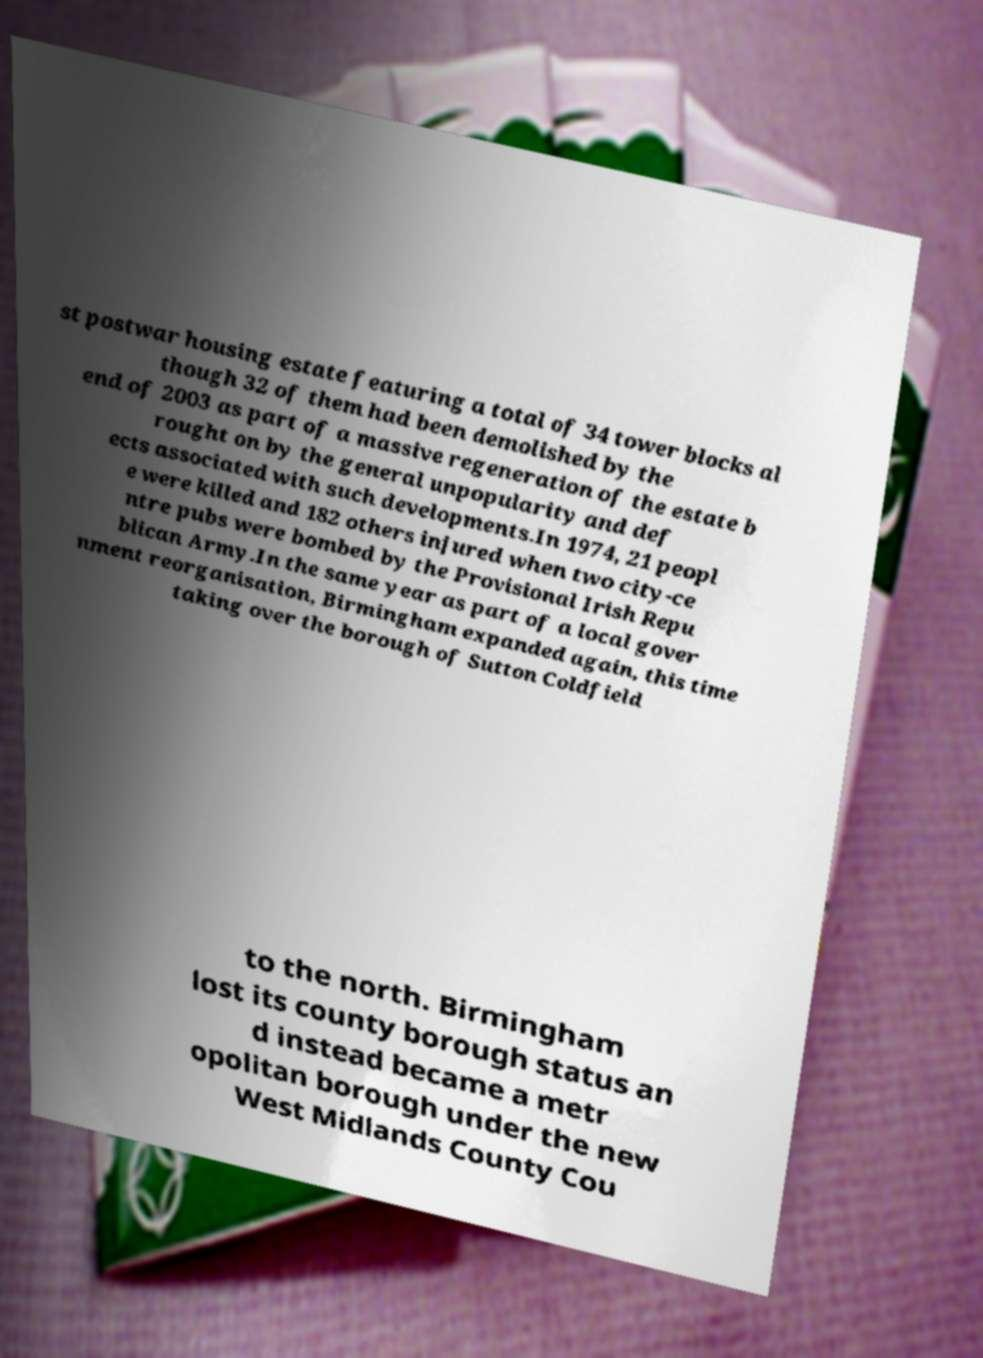For documentation purposes, I need the text within this image transcribed. Could you provide that? st postwar housing estate featuring a total of 34 tower blocks al though 32 of them had been demolished by the end of 2003 as part of a massive regeneration of the estate b rought on by the general unpopularity and def ects associated with such developments.In 1974, 21 peopl e were killed and 182 others injured when two city-ce ntre pubs were bombed by the Provisional Irish Repu blican Army.In the same year as part of a local gover nment reorganisation, Birmingham expanded again, this time taking over the borough of Sutton Coldfield to the north. Birmingham lost its county borough status an d instead became a metr opolitan borough under the new West Midlands County Cou 